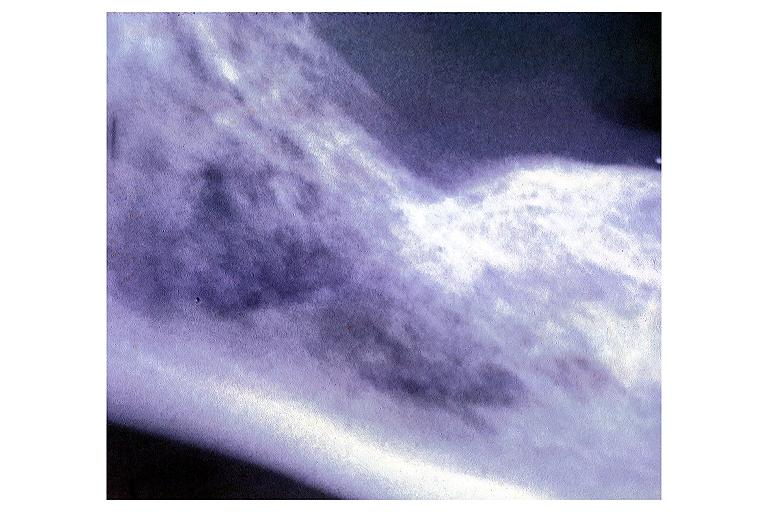where is this?
Answer the question using a single word or phrase. Oral 